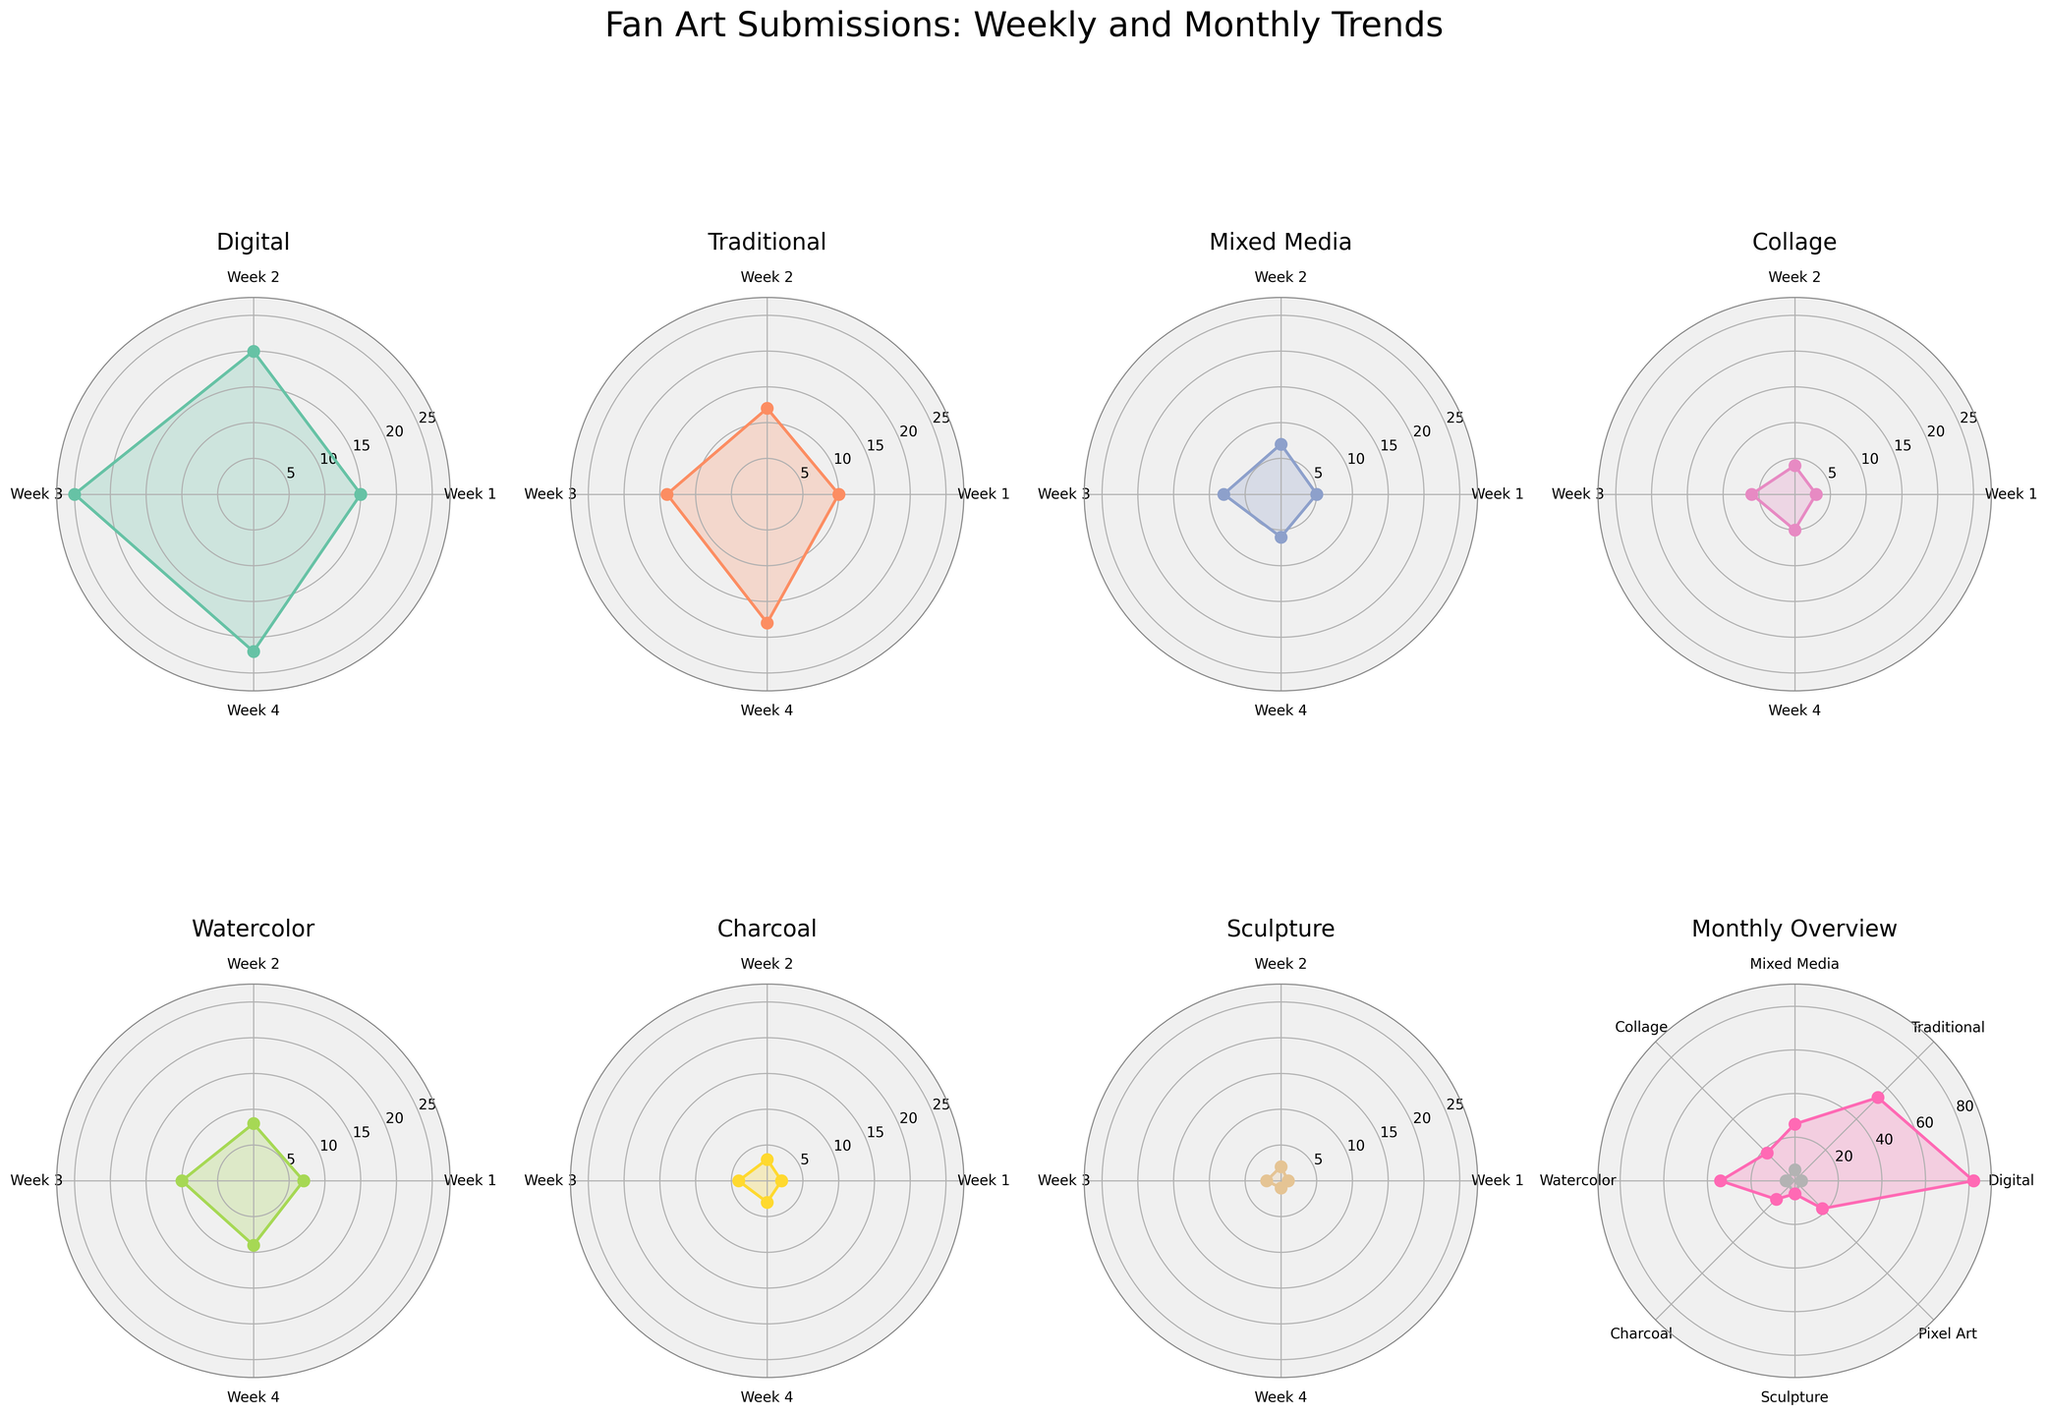What is the title of the entire figure? The title is centrally placed at the top of the figure and describes the overall data presented. It says "Fan Art Submissions: Weekly and Monthly Trends".
Answer: Fan Art Submissions: Weekly and Monthly Trends Which art style had the highest number of submissions in Week 3? By examining the third tick on each subplot, you can see that the Digital style has the highest value at 25 among all the styles for Week 3.
Answer: Digital What is the total number of submissions for the Traditional style over the four weeks? The values for Traditional in Weeks 1, 2, 3, and 4 are added together: 10 + 12 + 14 + 18 = 54.
Answer: 54 Which two art styles have the same number of submissions in Week 1? By looking at the first tick on each subplot, both Collage and Pixel Art have a value of 3 for Week 1.
Answer: Collage and Pixel Art How does the Mixed Media style compare to the Digital style on a monthly basis? In the monthly overview subplot, the submission for Mixed Media is 26, while Digital is at 82. Hence, the Digital style has a much higher monthly submission count compared to Mixed Media.
Answer: Digital has more What's the average number of submissions per week for Watercolor? Sum the weekly submissions for Watercolor: 7 + 8 + 10 + 9 = 34. Then, divide by the number of weeks, which is 4. So, 34 / 4 = 8.5.
Answer: 8.5 Which week had the highest overall submissions for Charcoal style? By examining the values for Charcoal in each week, Week 3 has the highest value at 4.
Answer: Week 3 How many more submissions did the Digital style have compared to the Sculpture style for Week 2? The Digital style had 20 submissions in Week 2, while the Sculpture style had 2. The difference is 20 - 2 = 18.
Answer: 18 In the monthly overview, how many styles have submission numbers greater than 50? By observing the values in the Monthly Overview subplot, only Digital (82) and Traditional (54) exceed 50. So, there are 2 styles.
Answer: 2 